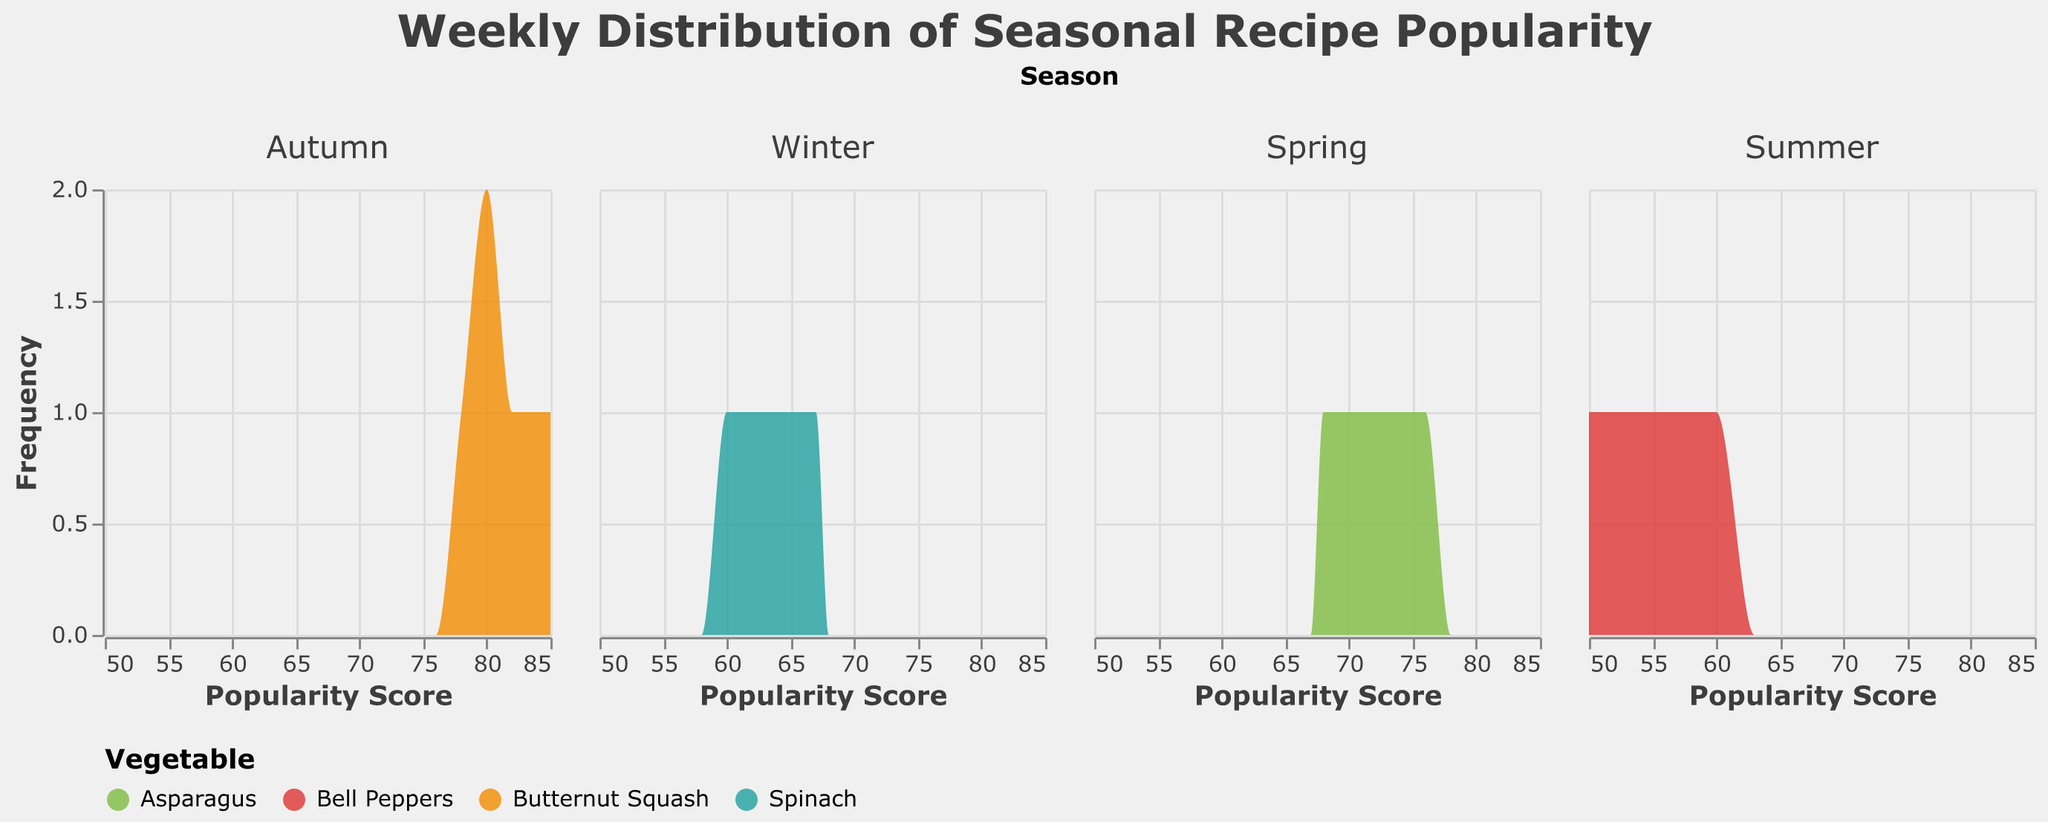What is the title of the figure? The title is usually placed at the top of the figure and provides an overview of what the figure is about. Looking at the top of the visual, we can see the title.
Answer: Weekly Distribution of Seasonal Recipe Popularity Which recipe appears most frequently in the Autumn subplot? In the Autumn subplot, I can see the colored area corresponding to each recipe. By the color coding and the legend, it shows that "Roasted Butternut Squash Soup" appears most frequently.
Answer: Roasted Butternut Squash Soup Which season shows the highest popularity score for any single recipe? By scanning across all the subplots, I look at the highest peaks on the x-axis labeled "Popularity Score". The highest peak appears in the Autumn subplot.
Answer: Autumn How does the popularity of Roasted Butternut Squash Soup compare to Spinach and Artichoke Dip over the weeks? I need to check the density plot areas and peaks associated with the colors corresponding to these recipes in the legend. Autumn (orange) shows consistently high popularity while Winter (green) shows lower.
Answer: More popular What is the approximate range of popularity scores for Grilled Asparagus Salad? By looking at the Spring subplot and the color coding for Grilled Asparagus Salad, I see that the popularity scores mostly range from the starting to near the end of the x-axis.
Answer: 68 to 76 Which vegetable is associated with the recipe that has the highest frequency in summer? By examining the Summer subplot, the recipe with the largest area under its density plot curve can be identified. According to the legend, Bell Peppers (red) corresponds to that recipe.
Answer: Bell Peppers Which season has the most distinct peak in recipe popularity and for which vegetable? By observing distinctness and sharpness of the peaks across all seasons' subplots, the Autumn subplot with Butternut Squash (orange) stands out the most.
Answer: Autumn, Butternut Squash What is the frequency of the most popular recipe in Spring? In the Spring subplot, the highest peak corresponds to the frequency. The peak reaches up to just below the number 1 on the y-axis.
Answer: Just below 1 